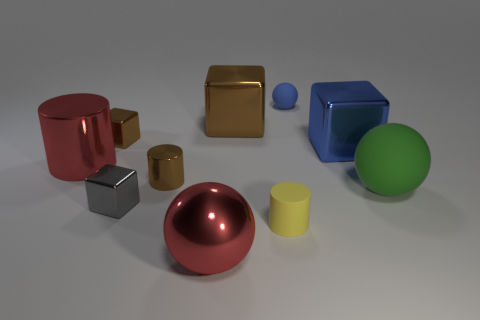Subtract all metal cylinders. How many cylinders are left? 1 Subtract all red spheres. How many spheres are left? 2 Subtract 0 green cylinders. How many objects are left? 10 Subtract all spheres. How many objects are left? 7 Subtract 3 spheres. How many spheres are left? 0 Subtract all yellow cylinders. Subtract all gray balls. How many cylinders are left? 2 Subtract all gray cylinders. How many blue cubes are left? 1 Subtract all large matte objects. Subtract all small metal cylinders. How many objects are left? 8 Add 8 big red balls. How many big red balls are left? 9 Add 6 big blue metal cubes. How many big blue metal cubes exist? 7 